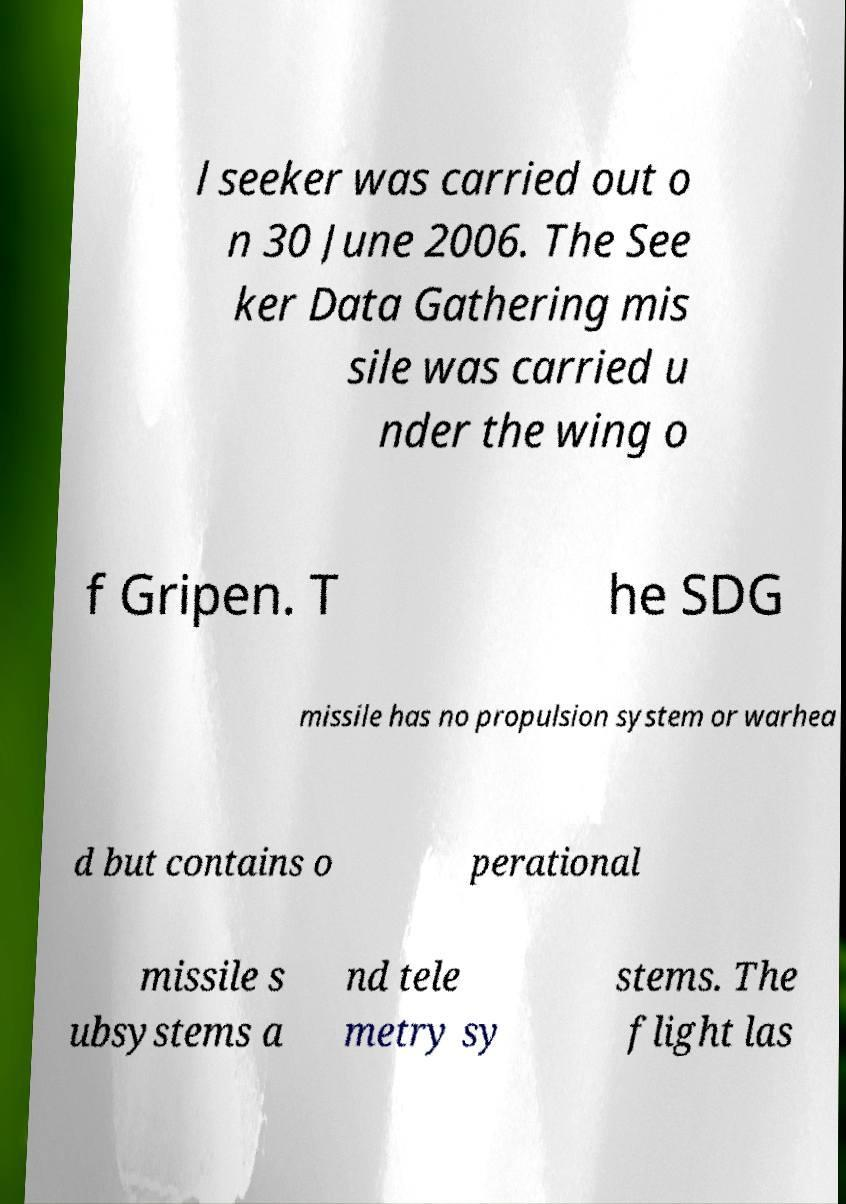For documentation purposes, I need the text within this image transcribed. Could you provide that? l seeker was carried out o n 30 June 2006. The See ker Data Gathering mis sile was carried u nder the wing o f Gripen. T he SDG missile has no propulsion system or warhea d but contains o perational missile s ubsystems a nd tele metry sy stems. The flight las 